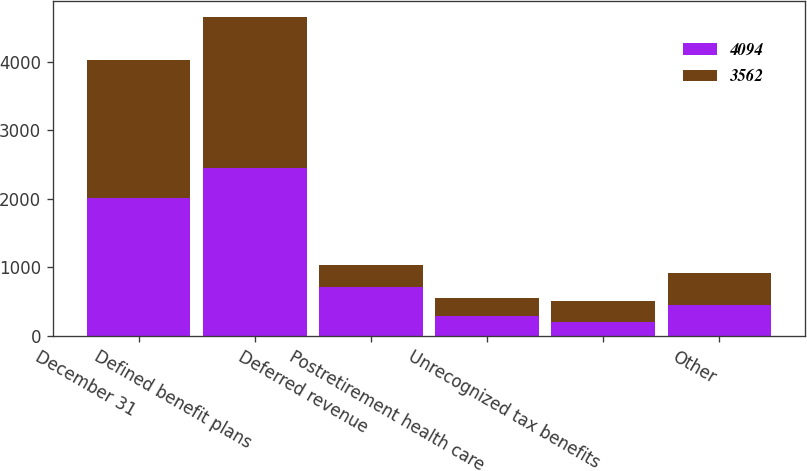Convert chart to OTSL. <chart><loc_0><loc_0><loc_500><loc_500><stacked_bar_chart><ecel><fcel>December 31<fcel>Defined benefit plans<fcel>Deferred revenue<fcel>Postretirement health care<fcel>Unrecognized tax benefits<fcel>Other<nl><fcel>4094<fcel>2009<fcel>2450<fcel>713<fcel>287<fcel>196<fcel>448<nl><fcel>3562<fcel>2008<fcel>2202<fcel>316<fcel>261<fcel>312<fcel>471<nl></chart> 